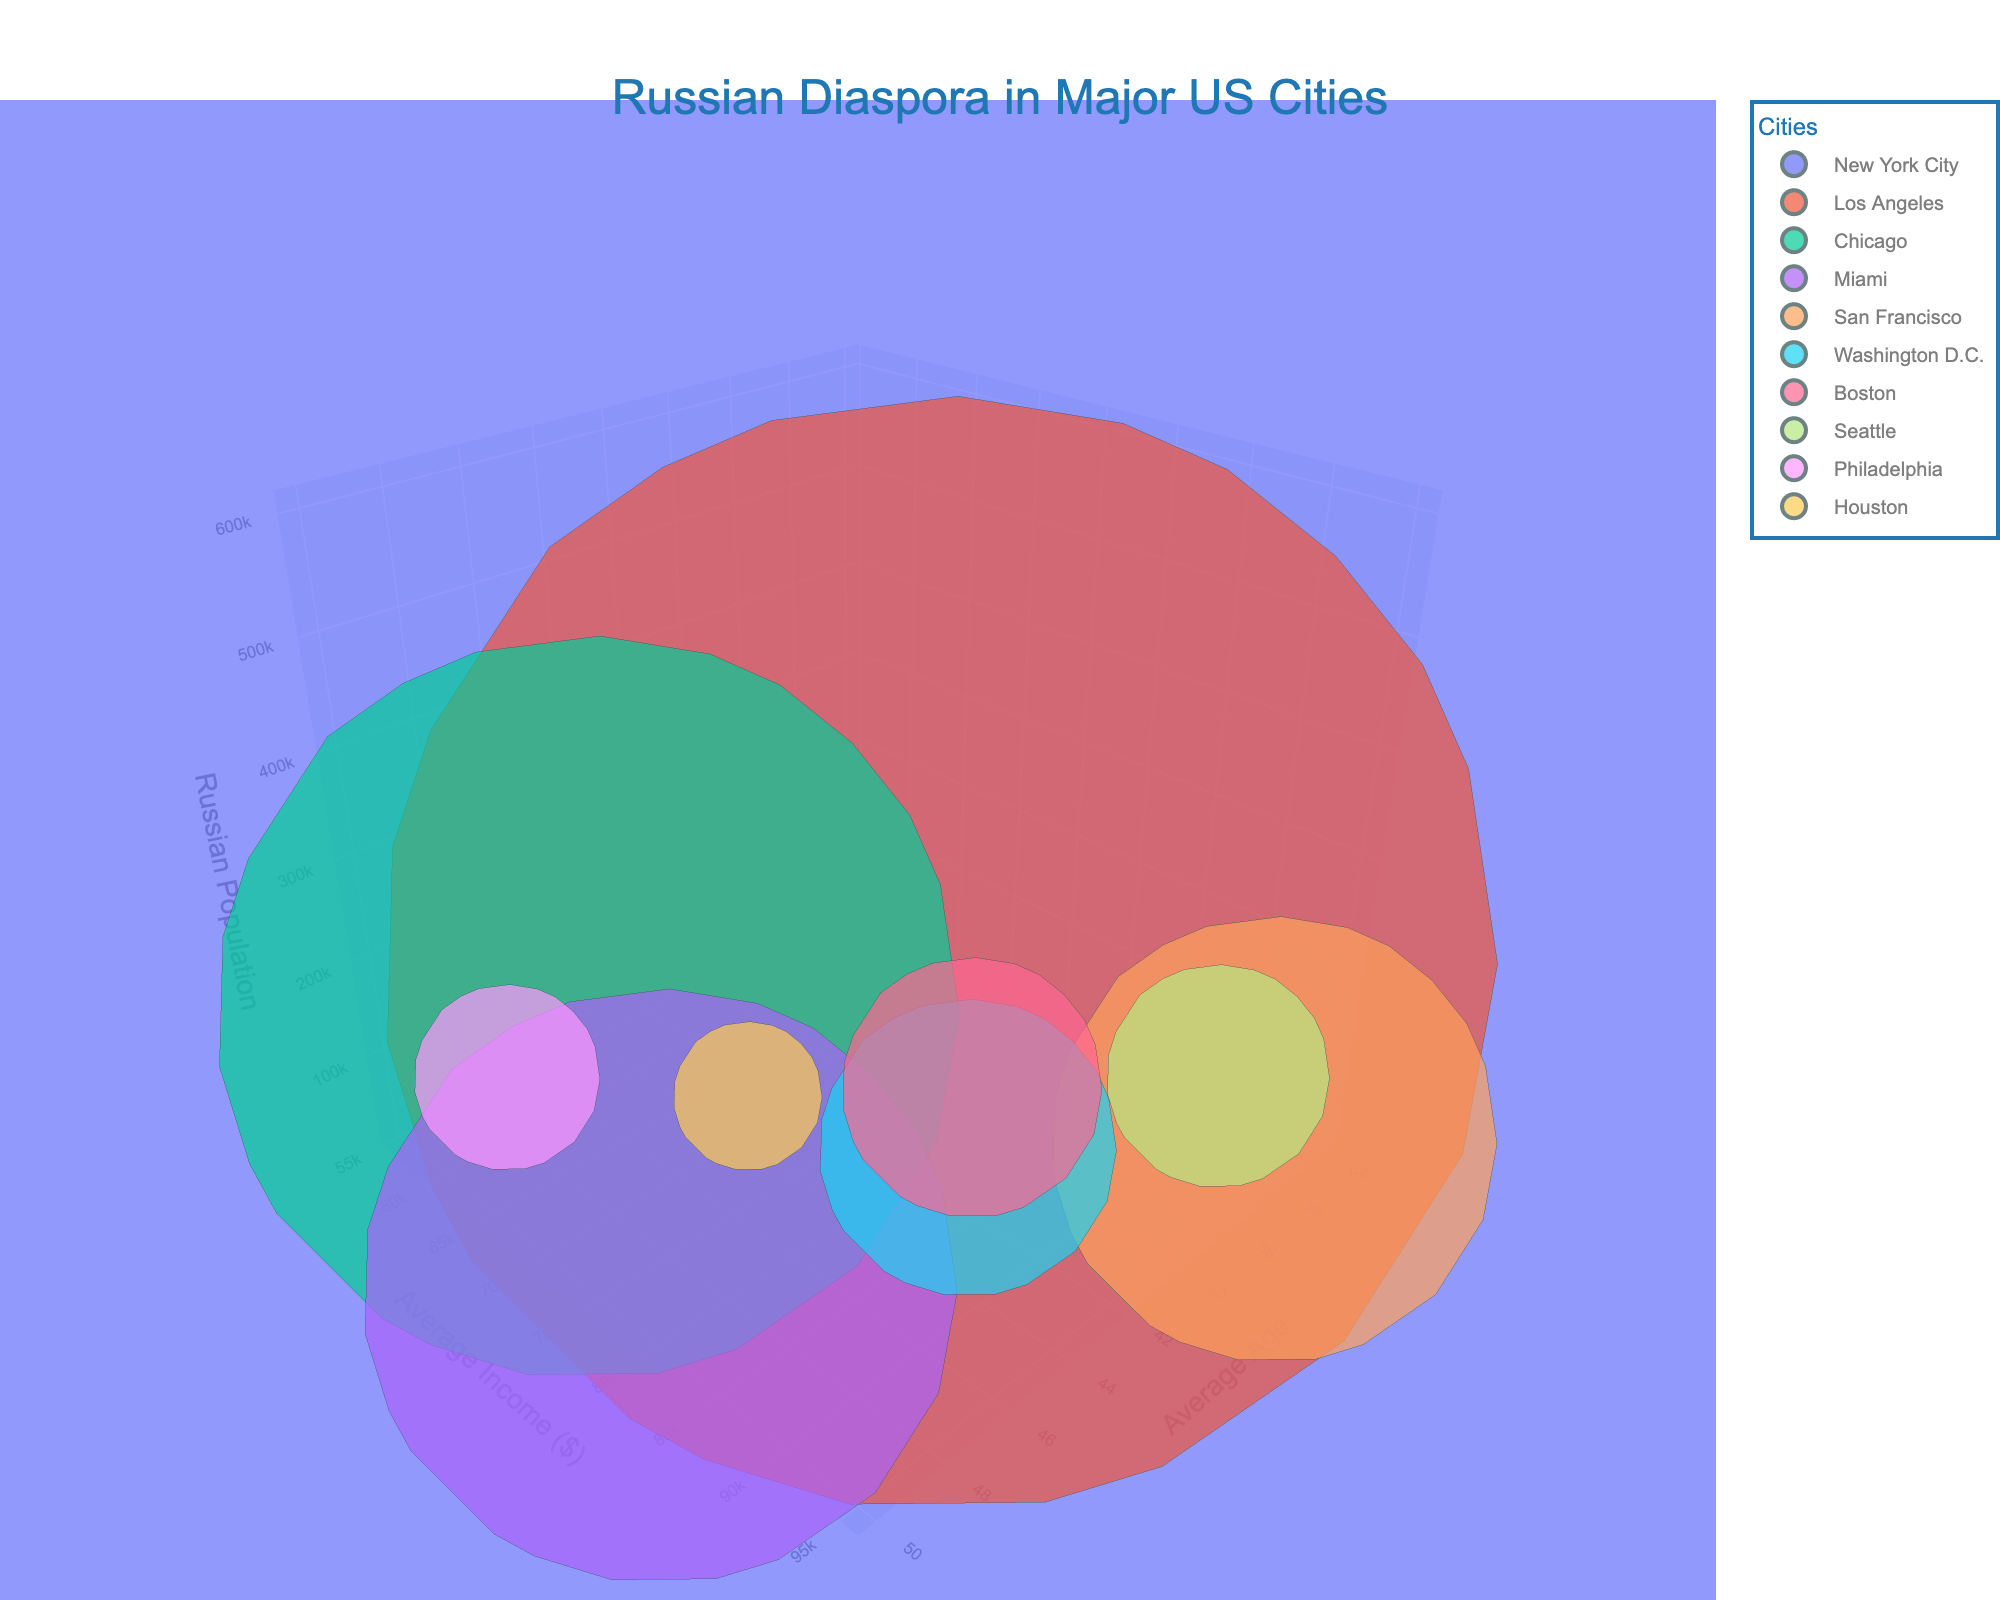What's the title of the figure? The title of the figure is displayed at the top, usually in a larger font size and with a different color to draw attention.
Answer: Russian Diaspora in Major US Cities Which city has the largest Russian population? The size of the bubbles represents the Russian population, with the largest bubble indicating the city with the highest population.
Answer: New York City What's the average age for the Russian community in Seattle? Locate the Seattle bubble and read the value on the x-axis, which represents the average age.
Answer: 34 Which city has a higher average income, Boston or Chicago? Compare the y-axis values for the Boston and Chicago bubbles to determine which one is higher.
Answer: Boston What's the combined Russian population for New York City and Los Angeles? Add the Russian populations of New York City and Los Angeles: 600,000 + 150,000 = 750,000.
Answer: 750,000 Is the average income higher in Miami or Washington D.C.? Identify and compare the y-axis values for Miami and Washington D.C.
Answer: Washington D.C Which city has the smallest Russian population? Find the smallest bubble on the z-axis, which indicates the smallest population.
Answer: Houston What's the average income difference between San Francisco and Philadelphia? Subtract the average income of Philadelphia from San Francisco: 95,000 - 56,000 = 39,000.
Answer: 39,000 How does the average age of the Russian population in New York City compare to that in San Francisco? Compare the x-axis values for New York City and San Francisco, identifying if it's greater or less.
Answer: Greater in New York City Which cities have an average age above 40 years for their Russian communities? Look for bubbles located above 40 years on the x-axis.
Answer: New York City, Chicago, Miami, Washington D.C, Houston 